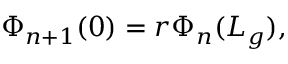<formula> <loc_0><loc_0><loc_500><loc_500>\Phi _ { n + 1 } ( 0 ) = r \Phi _ { n } ( L _ { g } ) ,</formula> 